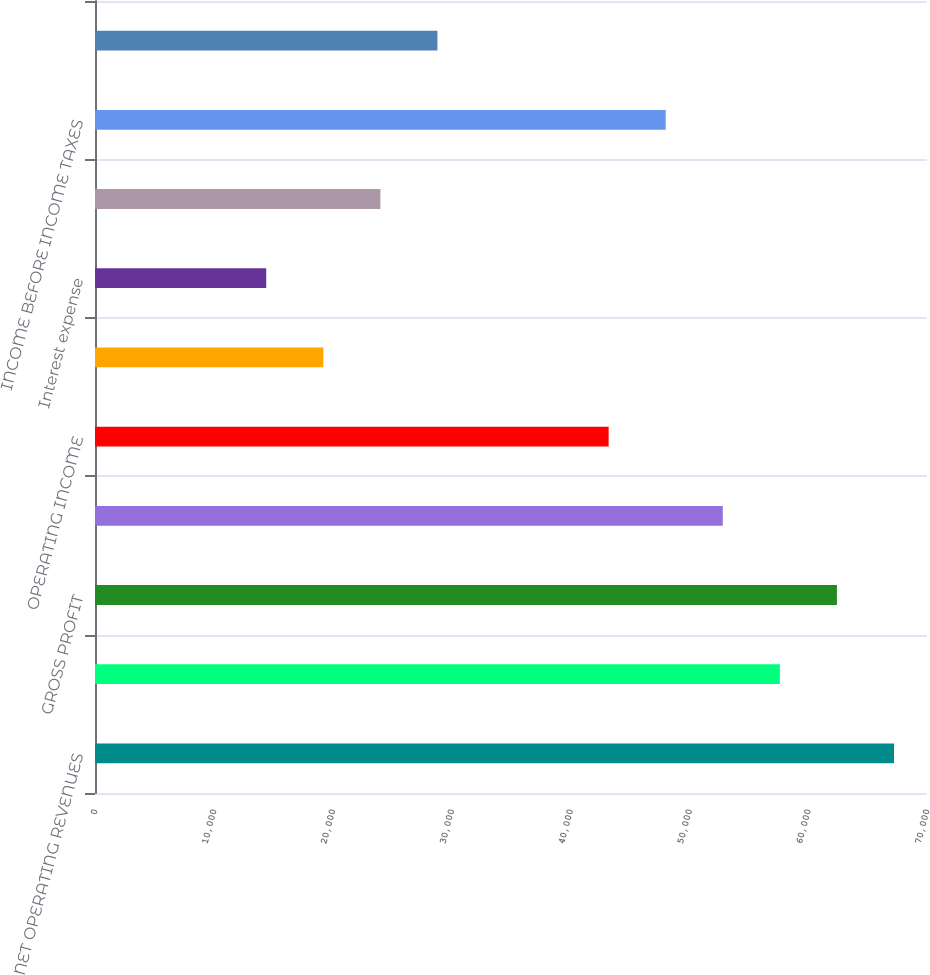Convert chart. <chart><loc_0><loc_0><loc_500><loc_500><bar_chart><fcel>NET OPERATING REVENUES<fcel>Cost of goods sold<fcel>GROSS PROFIT<fcel>Selling general and<fcel>OPERATING INCOME<fcel>Interest income<fcel>Interest expense<fcel>Equity income (loss) - net<fcel>INCOME BEFORE INCOME TAXES<fcel>Income taxes<nl><fcel>67223<fcel>57620<fcel>62421.5<fcel>52818.5<fcel>43215.5<fcel>19208<fcel>14406.5<fcel>24009.5<fcel>48017<fcel>28811<nl></chart> 